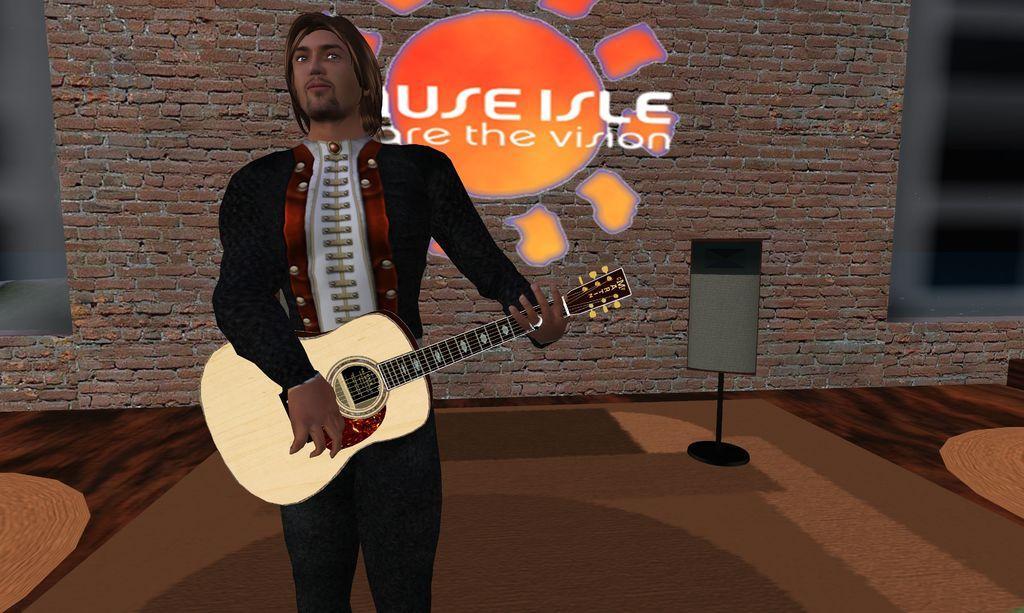Please provide a concise description of this image. In this picture I can see the depiction picture in which I see a man who is standing and holding a guitar in his hands and in the background I see the wall on which there is something written. 